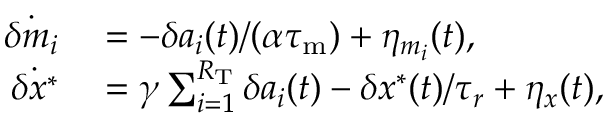Convert formula to latex. <formula><loc_0><loc_0><loc_500><loc_500>\begin{array} { r l } { \dot { \delta m _ { i } } } & = - \delta a _ { i } ( t ) / ( \alpha { \tau _ { m } } ) + \eta _ { m _ { i } } ( t ) , } \\ { \dot { \delta x ^ { \ast } } } & = \gamma \sum _ { i = 1 } ^ { R _ { T } } \delta a _ { i } ( t ) - \delta x ^ { * } ( t ) / \tau _ { r } + \eta _ { x } ( t ) , } \end{array}</formula> 